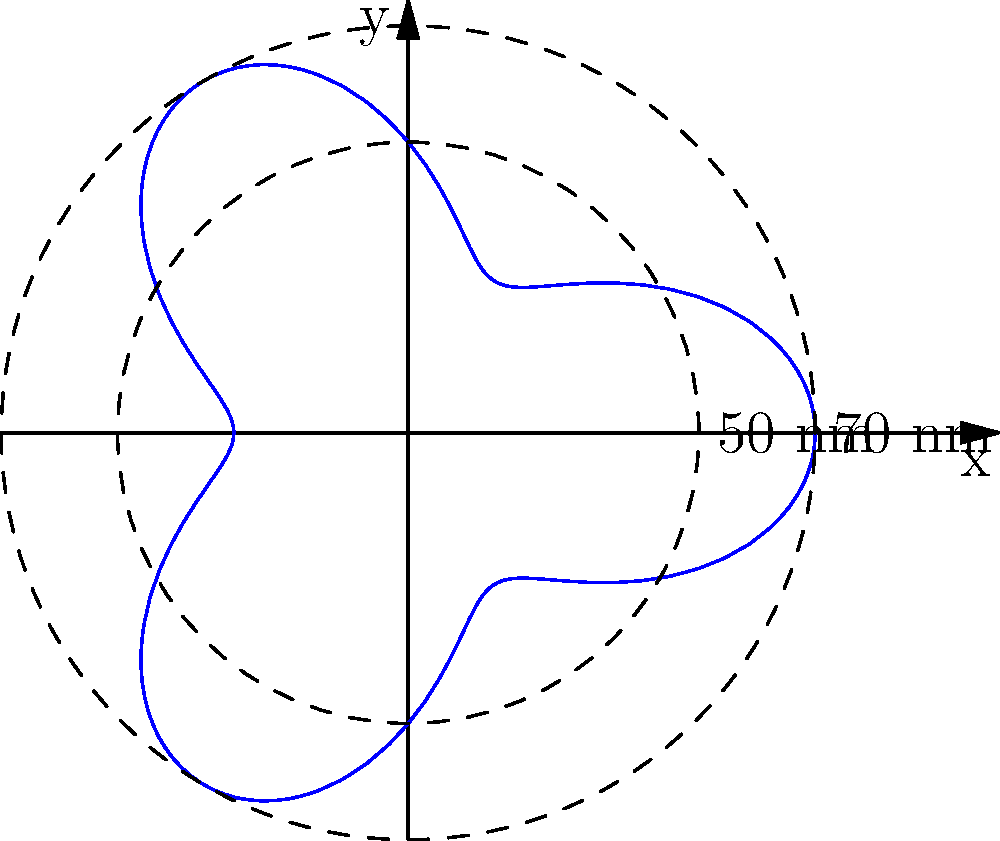A new radar system for aircraft detection has been developed with a unique coverage pattern. The polar equation of this pattern is given by $r = 50 + 20\cos(3\theta)$, where $r$ is in nautical miles (nm). What is the maximum range of this radar system, and at which angles (in radians) does this maximum occur within the interval $[0, 2\pi]$? To solve this problem, we need to follow these steps:

1) The maximum range will occur when $\cos(3\theta)$ is at its maximum value, which is 1.

2) When $\cos(3\theta) = 1$, the equation becomes:
   $r_{max} = 50 + 20(1) = 70$ nm

3) To find the angles at which this maximum occurs, we need to solve:
   $\cos(3\theta) = 1$

4) The general solution for this equation is:
   $3\theta = 2\pi n$, where $n$ is an integer

5) Solving for $\theta$:
   $\theta = \frac{2\pi n}{3}$

6) Within the interval $[0, 2\pi]$, this occurs three times:
   When $n = 0$: $\theta = 0$
   When $n = 1$: $\theta = \frac{2\pi}{3}$
   When $n = 2$: $\theta = \frac{4\pi}{3}$

Therefore, the maximum range is 70 nm, occurring at angles 0, $\frac{2\pi}{3}$, and $\frac{4\pi}{3}$ radians.
Answer: 70 nm; 0, $\frac{2\pi}{3}$, $\frac{4\pi}{3}$ radians 